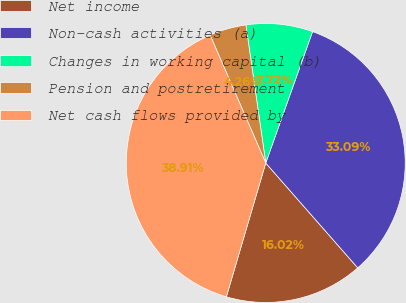<chart> <loc_0><loc_0><loc_500><loc_500><pie_chart><fcel>Net income<fcel>Non-cash activities (a)<fcel>Changes in working capital (b)<fcel>Pension and postretirement<fcel>Net cash flows provided by<nl><fcel>16.02%<fcel>33.09%<fcel>7.72%<fcel>4.26%<fcel>38.91%<nl></chart> 